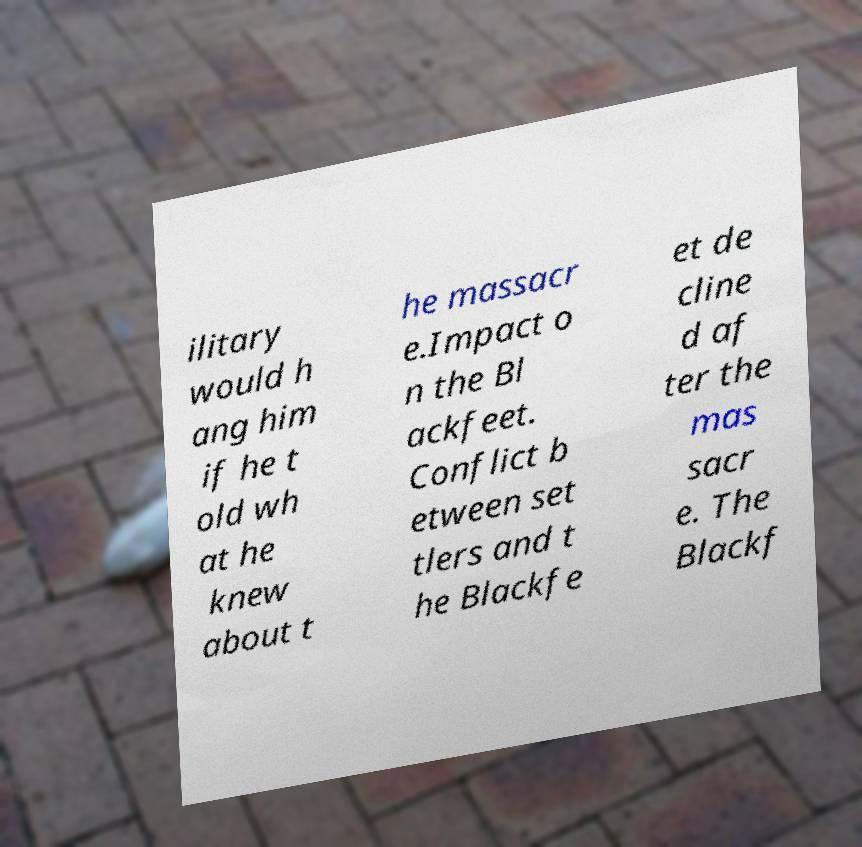Please read and relay the text visible in this image. What does it say? ilitary would h ang him if he t old wh at he knew about t he massacr e.Impact o n the Bl ackfeet. Conflict b etween set tlers and t he Blackfe et de cline d af ter the mas sacr e. The Blackf 